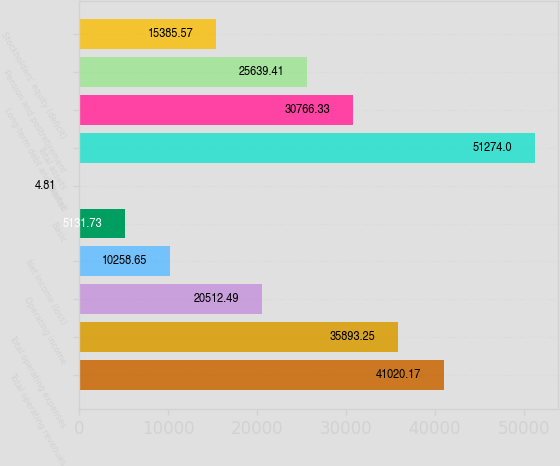Convert chart to OTSL. <chart><loc_0><loc_0><loc_500><loc_500><bar_chart><fcel>Total operating revenues<fcel>Total operating expenses<fcel>Operating income<fcel>Net income (loss)<fcel>Basic<fcel>Diluted<fcel>Total assets<fcel>Long-term debt and capital<fcel>Pension and postretirement<fcel>Stockholders' equity (deficit)<nl><fcel>41020.2<fcel>35893.2<fcel>20512.5<fcel>10258.6<fcel>5131.73<fcel>4.81<fcel>51274<fcel>30766.3<fcel>25639.4<fcel>15385.6<nl></chart> 